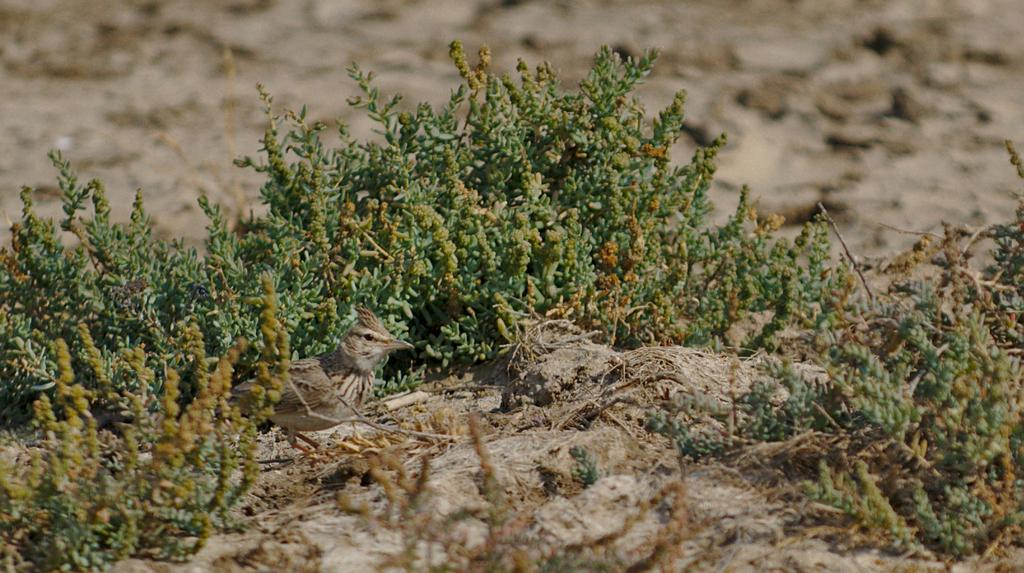What type of living organisms can be seen in the image? Plants can be seen in the image. What animal is present on the floor in the image? There is a bird on the floor in the image. What type of trucks can be seen in the image? There are no trucks present in the image. What type of cream is being used in the office setting depicted in the image? There is no office or cream present in the image; it features plants and a bird on the floor. 